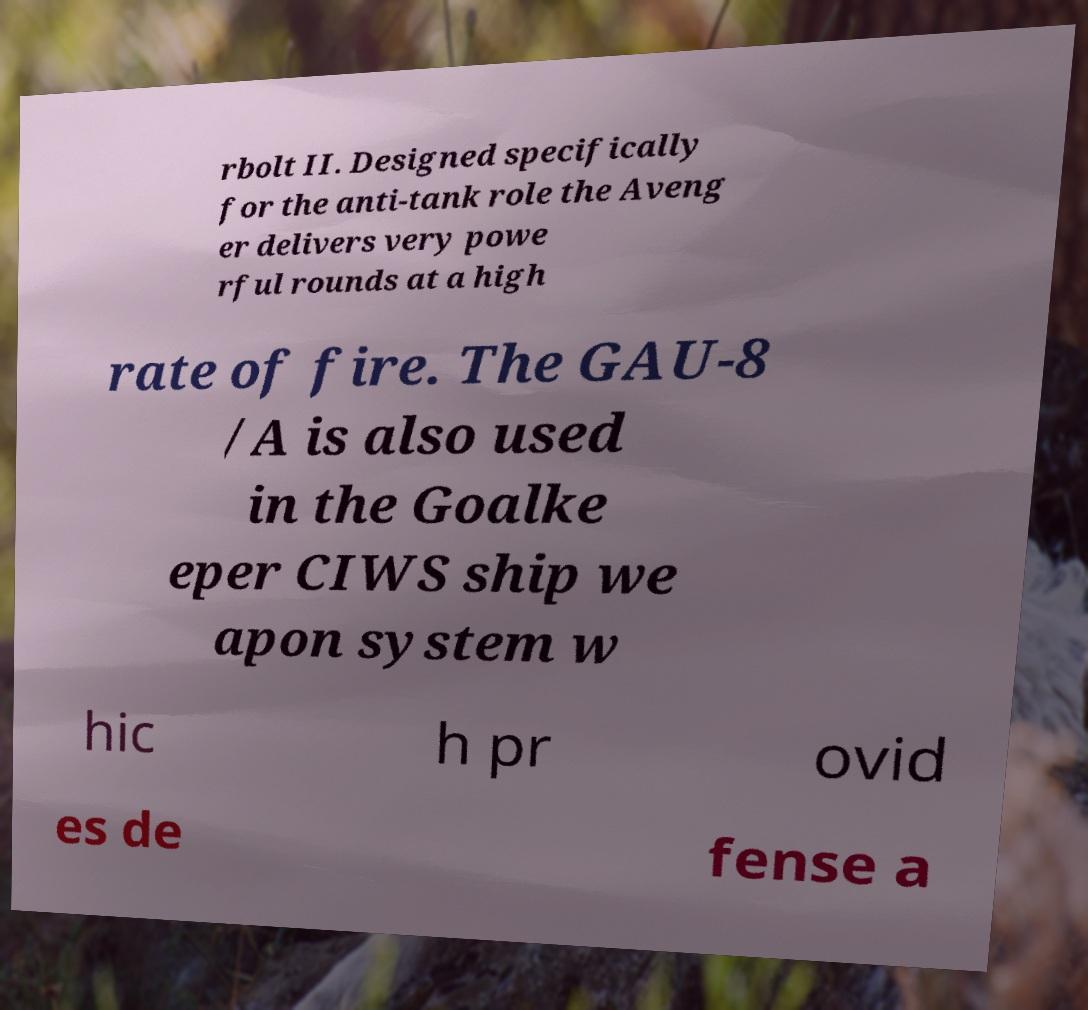Can you read and provide the text displayed in the image?This photo seems to have some interesting text. Can you extract and type it out for me? rbolt II. Designed specifically for the anti-tank role the Aveng er delivers very powe rful rounds at a high rate of fire. The GAU-8 /A is also used in the Goalke eper CIWS ship we apon system w hic h pr ovid es de fense a 